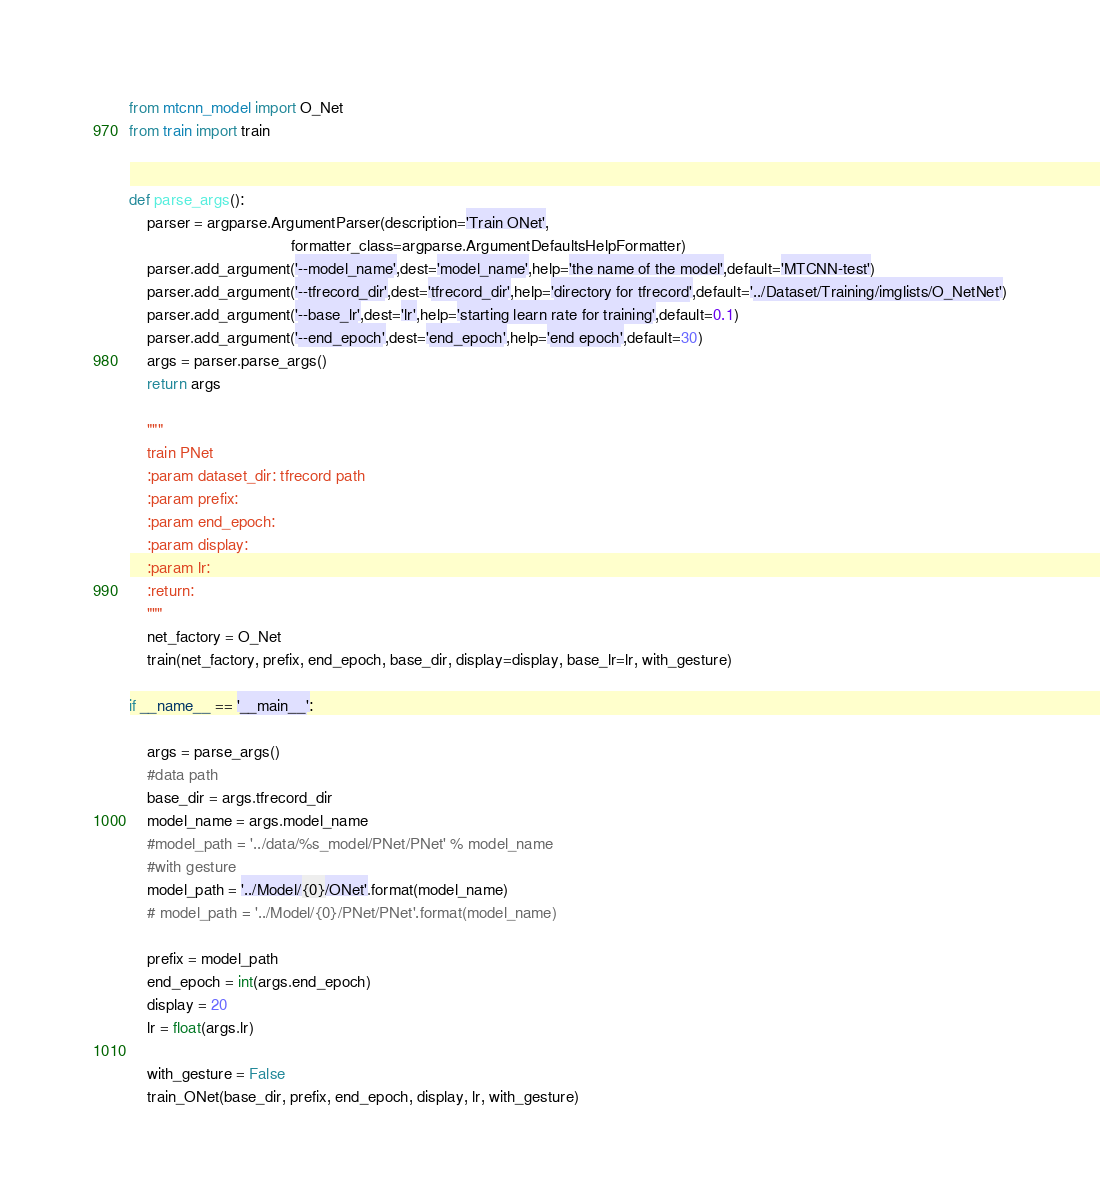Convert code to text. <code><loc_0><loc_0><loc_500><loc_500><_Python_>from mtcnn_model import O_Net
from train import train


def parse_args():
    parser = argparse.ArgumentParser(description='Train ONet',
                                     formatter_class=argparse.ArgumentDefaultsHelpFormatter)
    parser.add_argument('--model_name',dest='model_name',help='the name of the model',default='MTCNN-test')
    parser.add_argument('--tfrecord_dir',dest='tfrecord_dir',help='directory for tfrecord',default='../Dataset/Training/imglists/O_NetNet')
    parser.add_argument('--base_lr',dest='lr',help='starting learn rate for training',default=0.1)
    parser.add_argument('--end_epoch',dest='end_epoch',help='end epoch',default=30)
    args = parser.parse_args()
    return args

    """
    train PNet
    :param dataset_dir: tfrecord path
    :param prefix:
    :param end_epoch:
    :param display:
    :param lr:
    :return:
    """
    net_factory = O_Net
    train(net_factory, prefix, end_epoch, base_dir, display=display, base_lr=lr, with_gesture)

if __name__ == '__main__':
 
    args = parse_args()
    #data path
    base_dir = args.tfrecord_dir
    model_name = args.model_name
    #model_path = '../data/%s_model/PNet/PNet' % model_name
    #with gesture
    model_path = '../Model/{0}/ONet'.format(model_name)
    # model_path = '../Model/{0}/PNet/PNet'.format(model_name)
    
    prefix = model_path
    end_epoch = int(args.end_epoch)
    display = 20
    lr = float(args.lr)

    with_gesture = False
    train_ONet(base_dir, prefix, end_epoch, display, lr, with_gesture)
</code> 